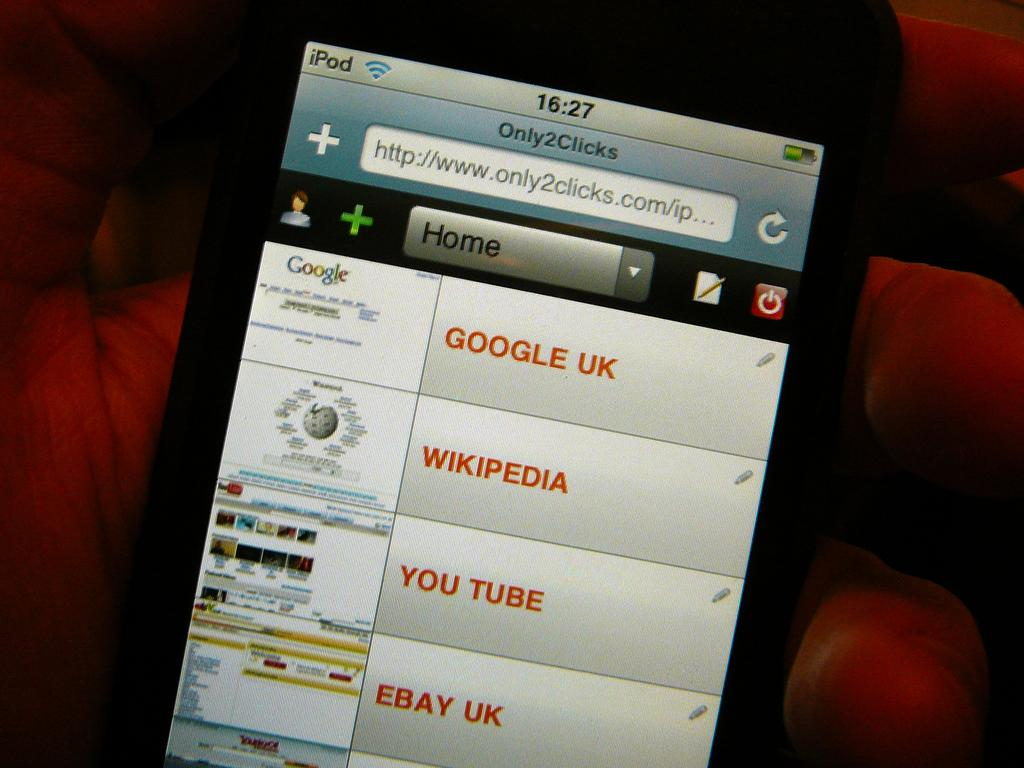Provide a one-sentence caption for the provided image. The screen of a cell phone with tabs for Google UK, Wikipedia, and other sites showing. 